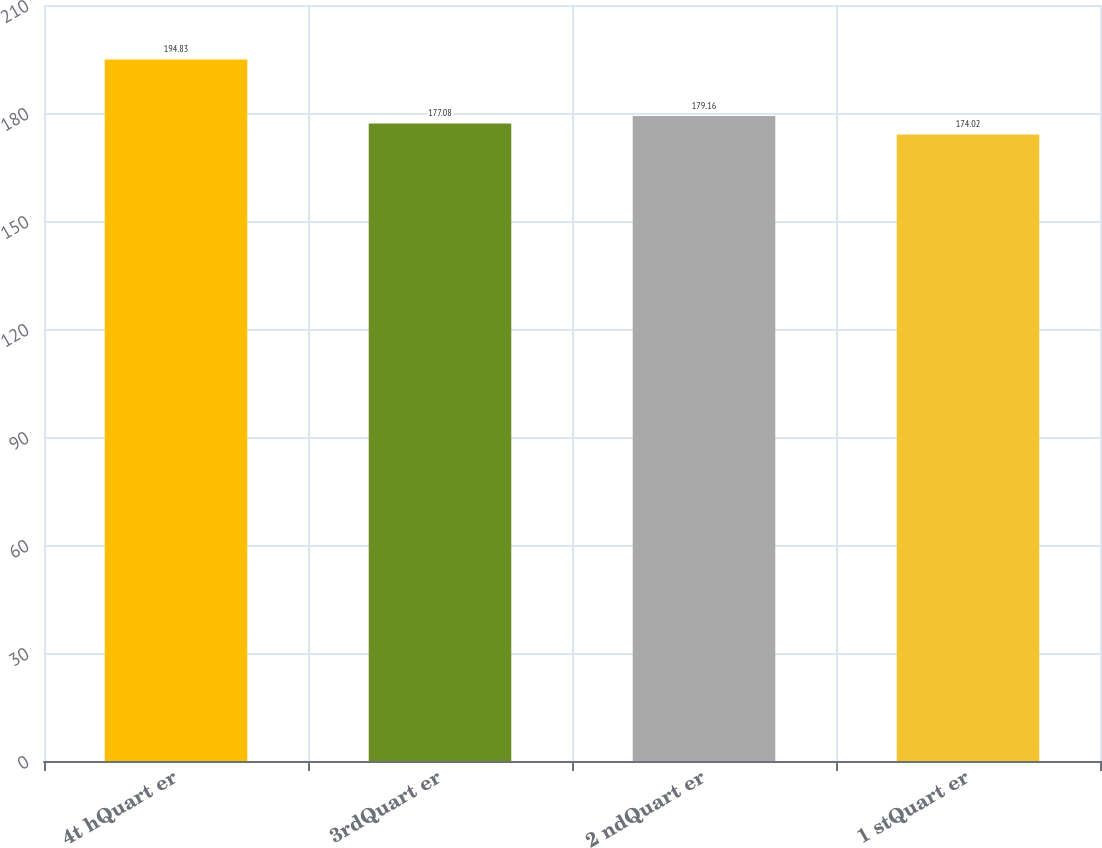Convert chart. <chart><loc_0><loc_0><loc_500><loc_500><bar_chart><fcel>4t hQuart er<fcel>3rdQuart er<fcel>2 ndQuart er<fcel>1 stQuart er<nl><fcel>194.83<fcel>177.08<fcel>179.16<fcel>174.02<nl></chart> 